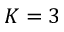Convert formula to latex. <formula><loc_0><loc_0><loc_500><loc_500>K = 3</formula> 